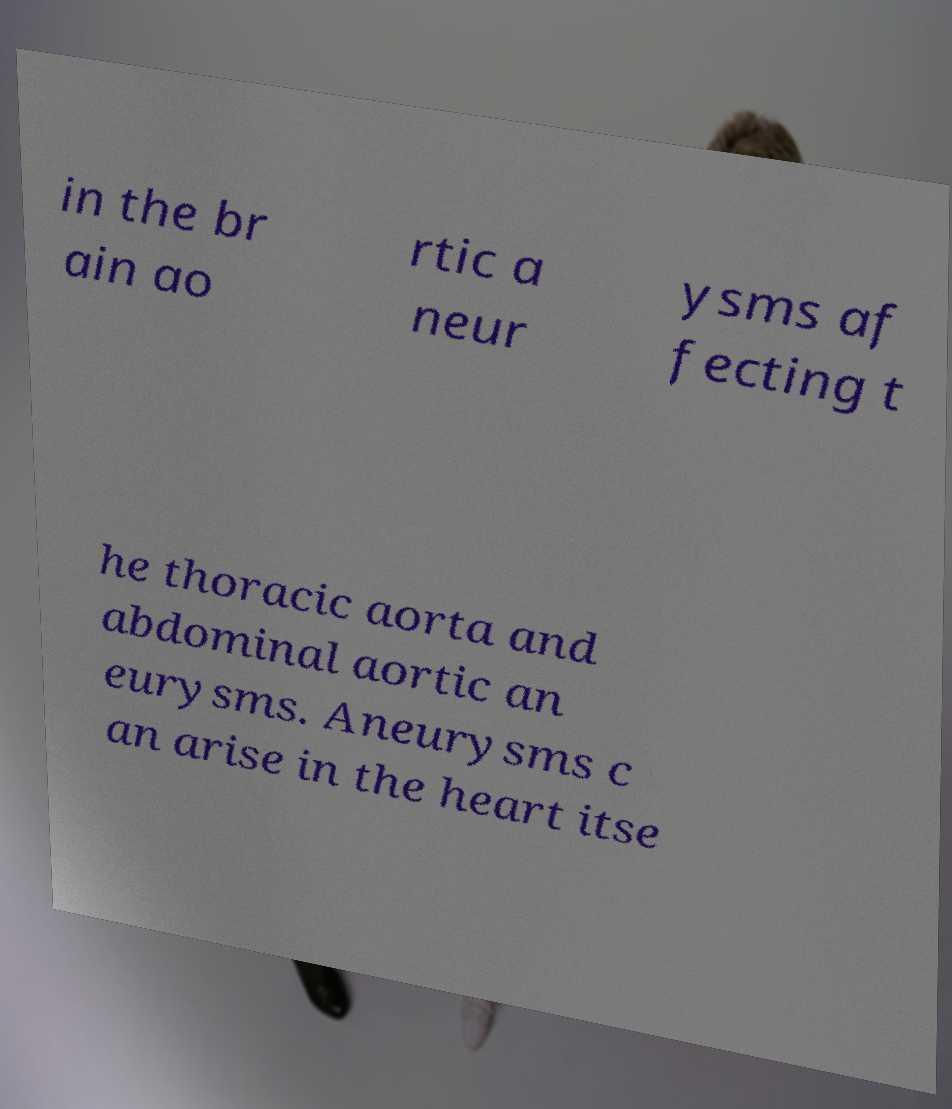For documentation purposes, I need the text within this image transcribed. Could you provide that? in the br ain ao rtic a neur ysms af fecting t he thoracic aorta and abdominal aortic an eurysms. Aneurysms c an arise in the heart itse 